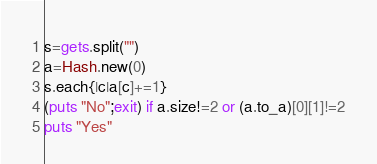<code> <loc_0><loc_0><loc_500><loc_500><_Ruby_>s=gets.split("")
a=Hash.new(0)
s.each{|c|a[c]+=1}
(puts "No";exit) if a.size!=2 or (a.to_a)[0][1]!=2
puts "Yes"</code> 